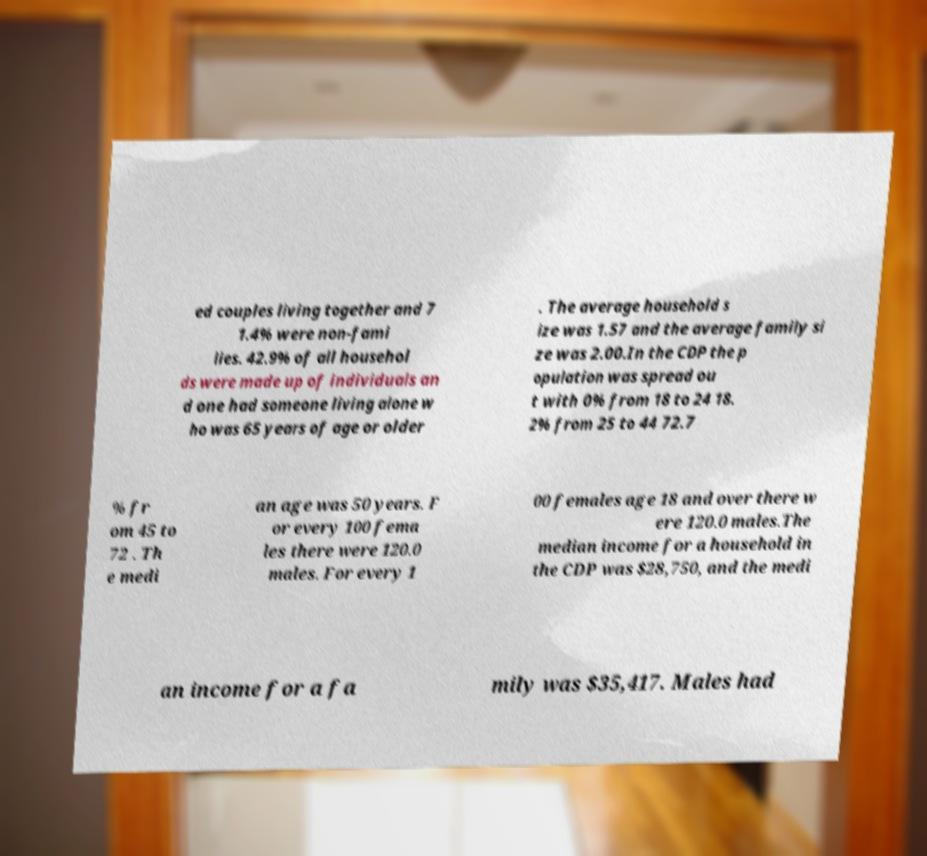What messages or text are displayed in this image? I need them in a readable, typed format. ed couples living together and 7 1.4% were non-fami lies. 42.9% of all househol ds were made up of individuals an d one had someone living alone w ho was 65 years of age or older . The average household s ize was 1.57 and the average family si ze was 2.00.In the CDP the p opulation was spread ou t with 0% from 18 to 24 18. 2% from 25 to 44 72.7 % fr om 45 to 72 . Th e medi an age was 50 years. F or every 100 fema les there were 120.0 males. For every 1 00 females age 18 and over there w ere 120.0 males.The median income for a household in the CDP was $28,750, and the medi an income for a fa mily was $35,417. Males had 